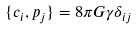Convert formula to latex. <formula><loc_0><loc_0><loc_500><loc_500>\{ c _ { i } , p _ { j } \} = 8 \pi G \gamma \delta _ { i j }</formula> 